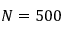Convert formula to latex. <formula><loc_0><loc_0><loc_500><loc_500>N = 5 0 0</formula> 